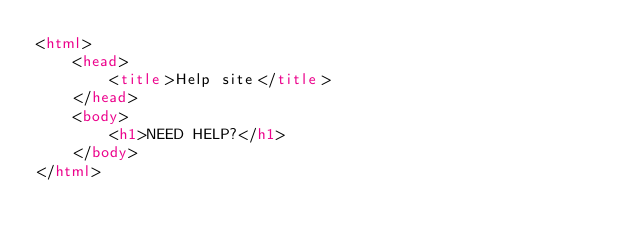<code> <loc_0><loc_0><loc_500><loc_500><_HTML_><html>
    <head>
        <title>Help site</title>
    </head>
    <body>
        <h1>NEED HELP?</h1>
    </body>
</html></code> 